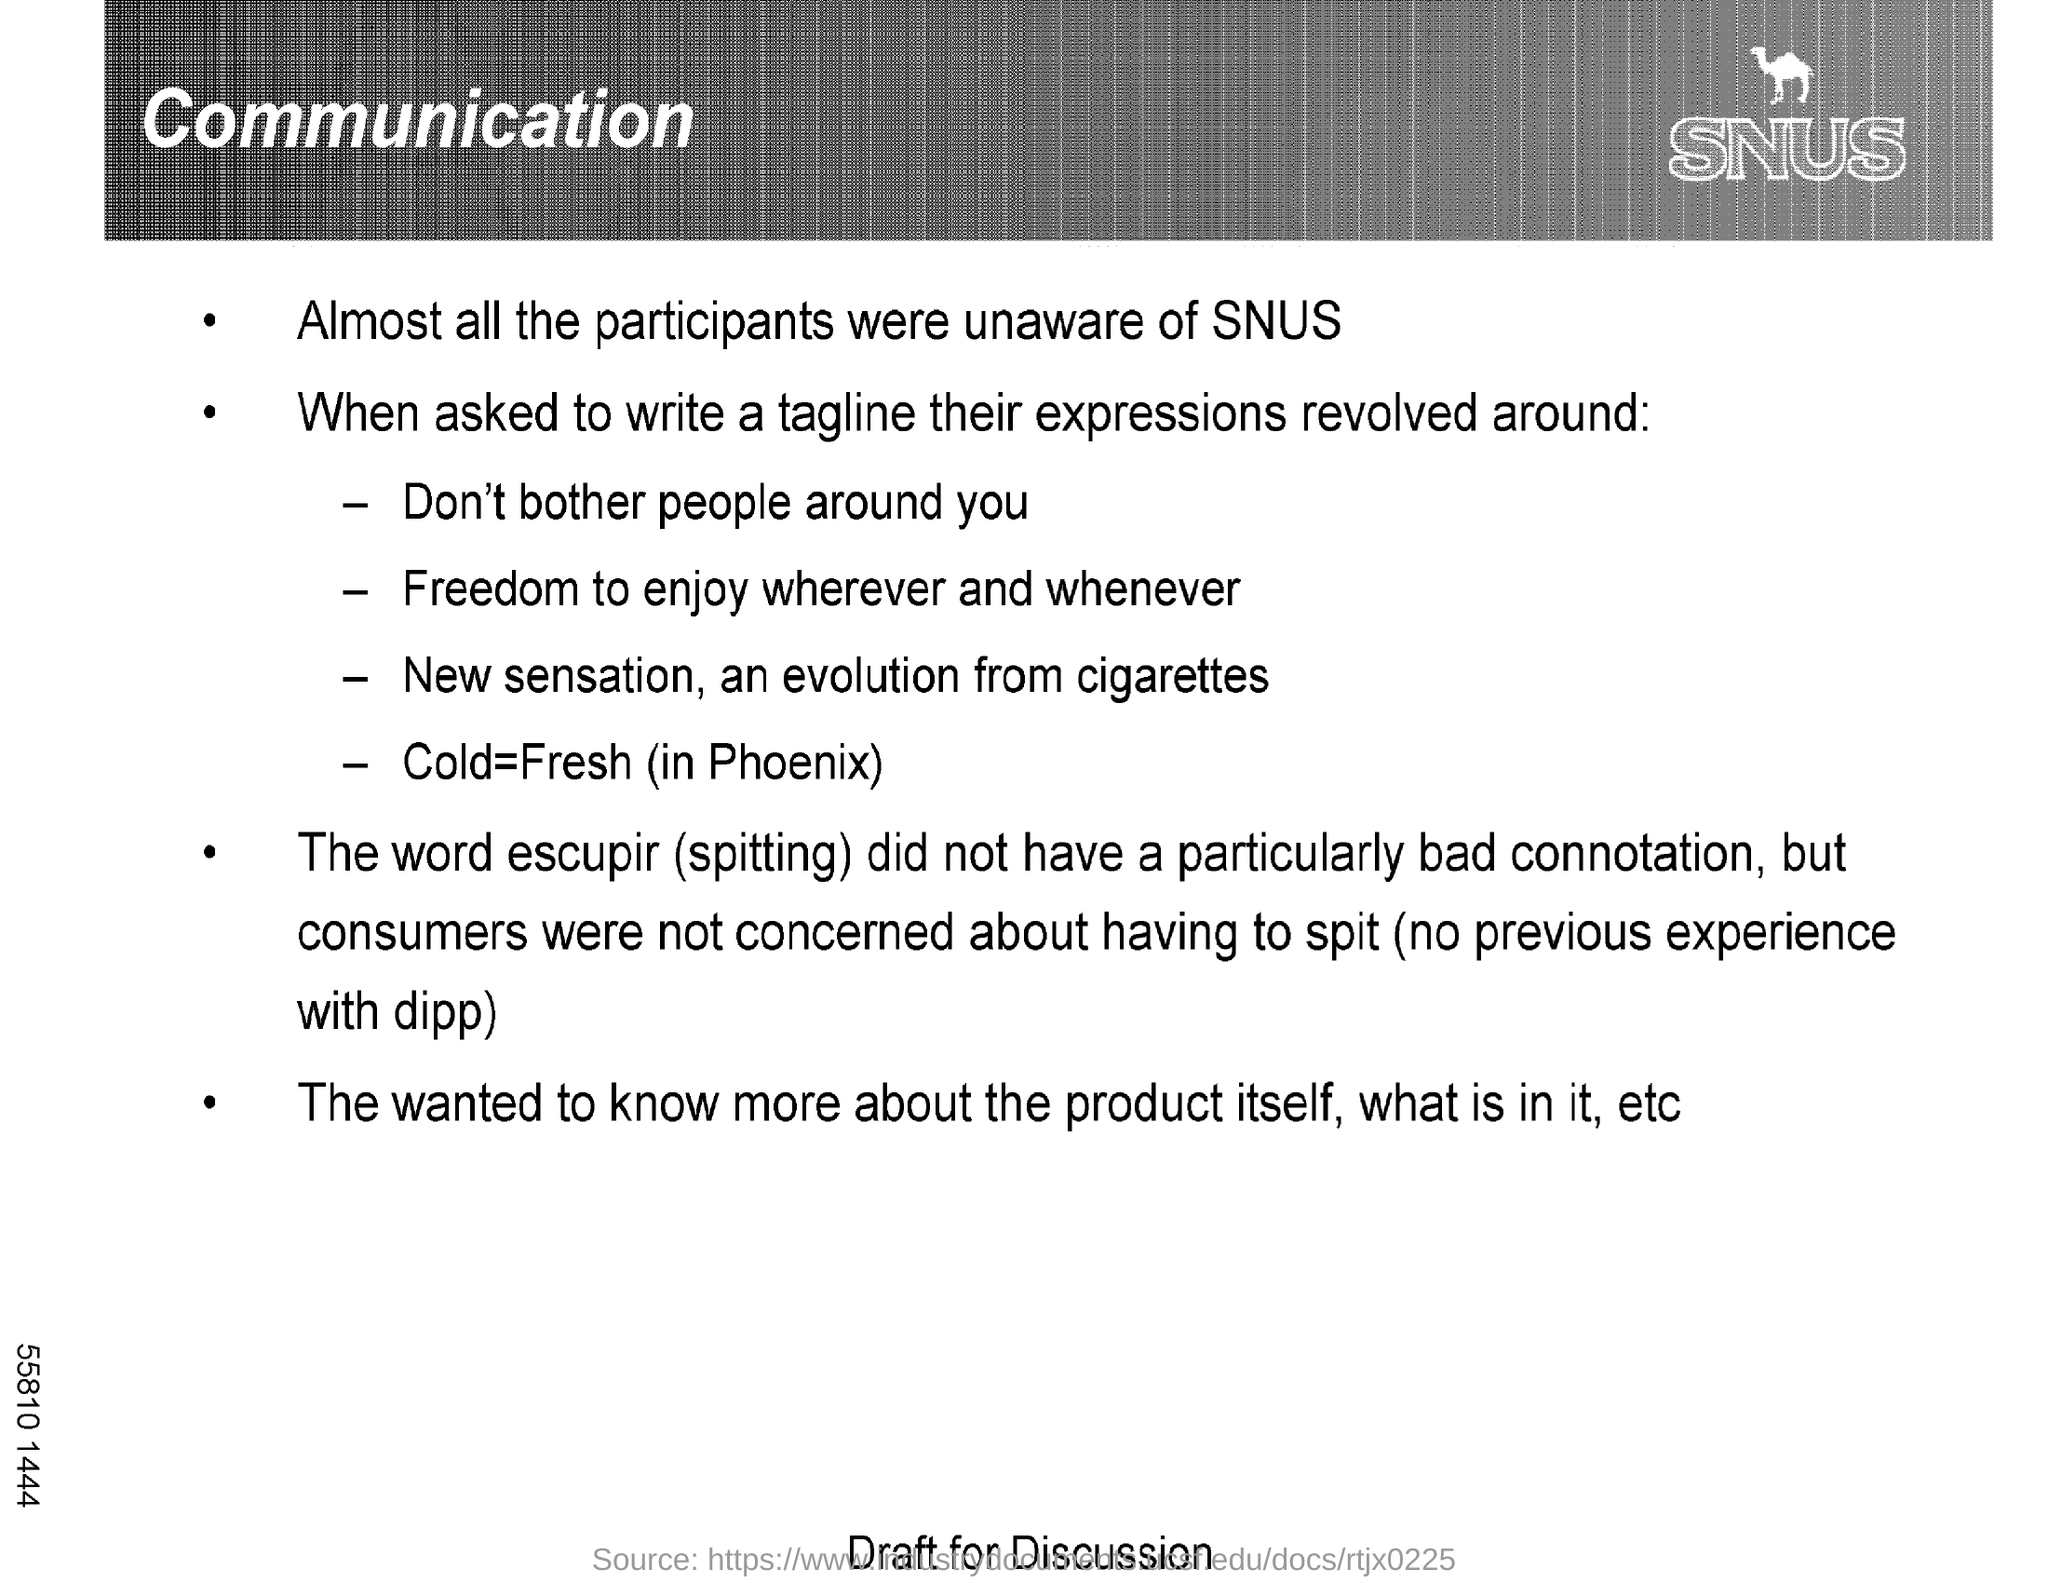List a handful of essential elements in this visual. It is imperative to refrain from disturbing those around you by mentioning the first tagline in the document. The word "Escupir" means "spitting. 